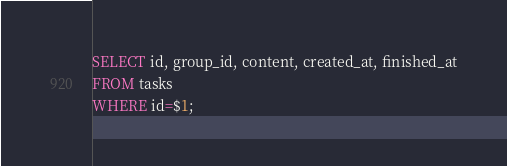<code> <loc_0><loc_0><loc_500><loc_500><_SQL_>SELECT id, group_id, content, created_at, finished_at
FROM tasks
WHERE id=$1;</code> 